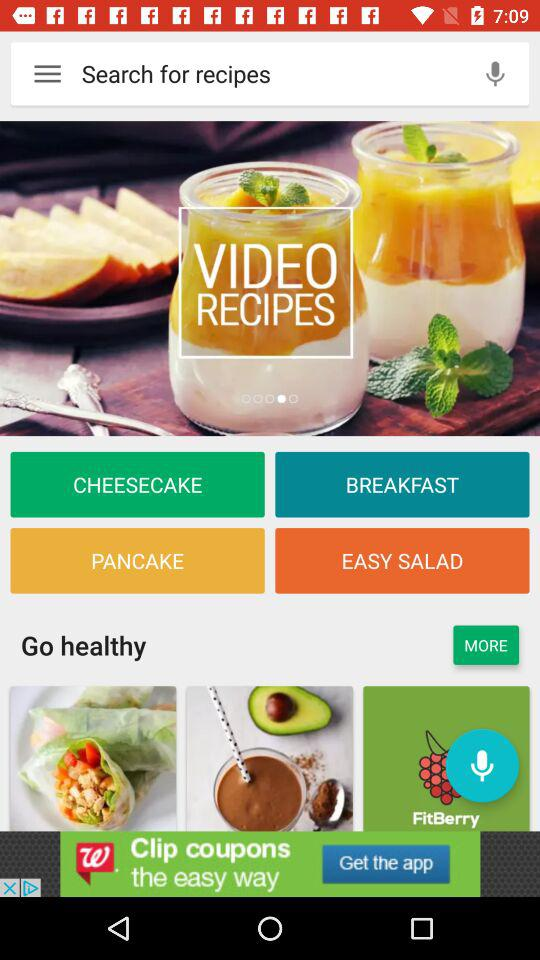What are the categories for which video recipes are available? The categories for which video recipes are available are "CHEESECAKE", "BREAKFAST", "PANCAKE" and "'EASY SALAD". 